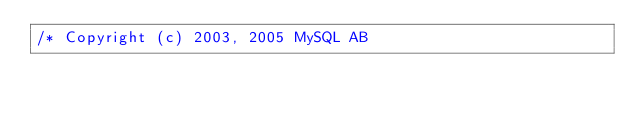Convert code to text. <code><loc_0><loc_0><loc_500><loc_500><_C++_>/* Copyright (c) 2003, 2005 MySQL AB
</code> 